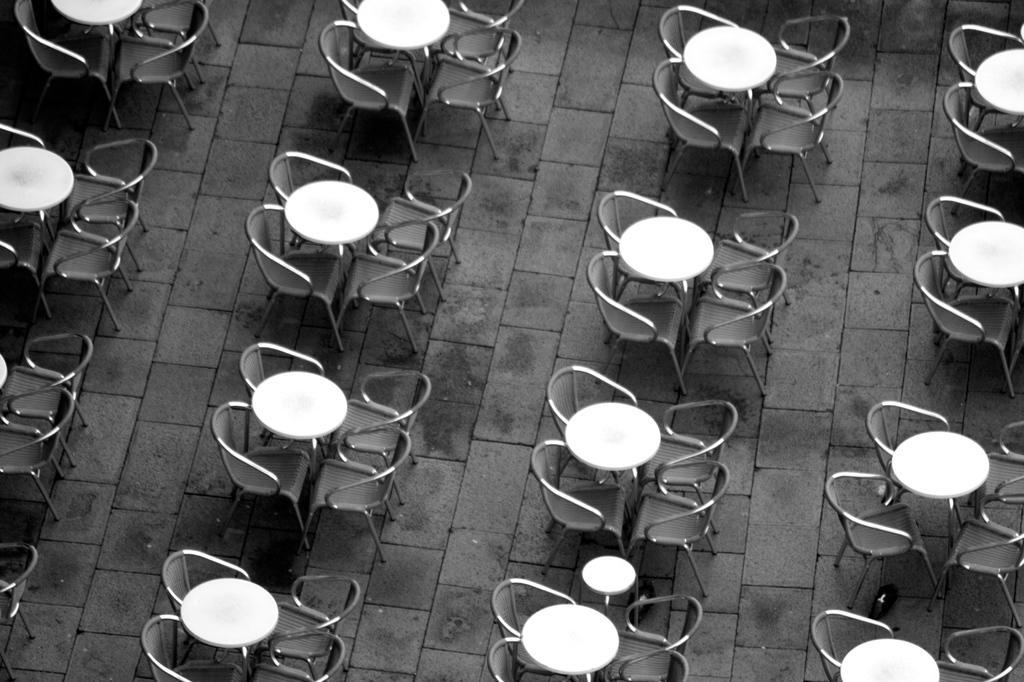Could you give a brief overview of what you see in this image? This is a black and white image. In this picture we can see tables and chairs. In the background of the image we can see the floor. 